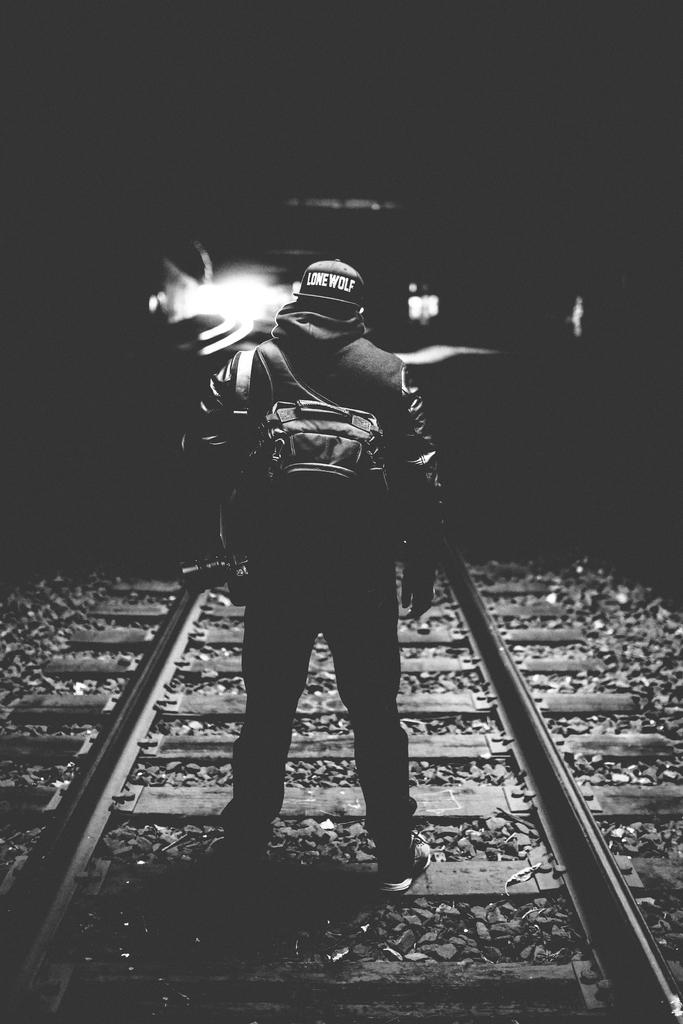What is the main subject of the image? There is a person in the image. What is the person wearing? The person is wearing a dress, a bag, and a helmet. Where is the person standing? The person is standing on a track. What is the color of the background in the image? The background of the image is black. Is the writer of the image present in the image? There is no writer present in the image; it is a photograph or illustration of a person. How many eggs are visible in the image? There are no eggs present in the image. 